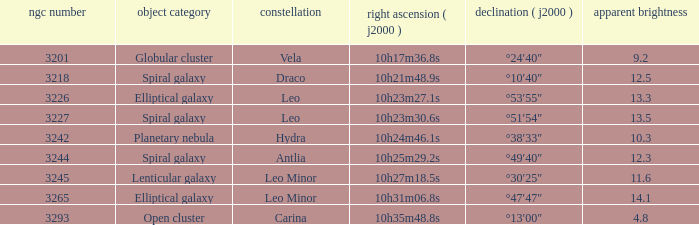What is the sum of NGC numbers for Constellation vela? 3201.0. 